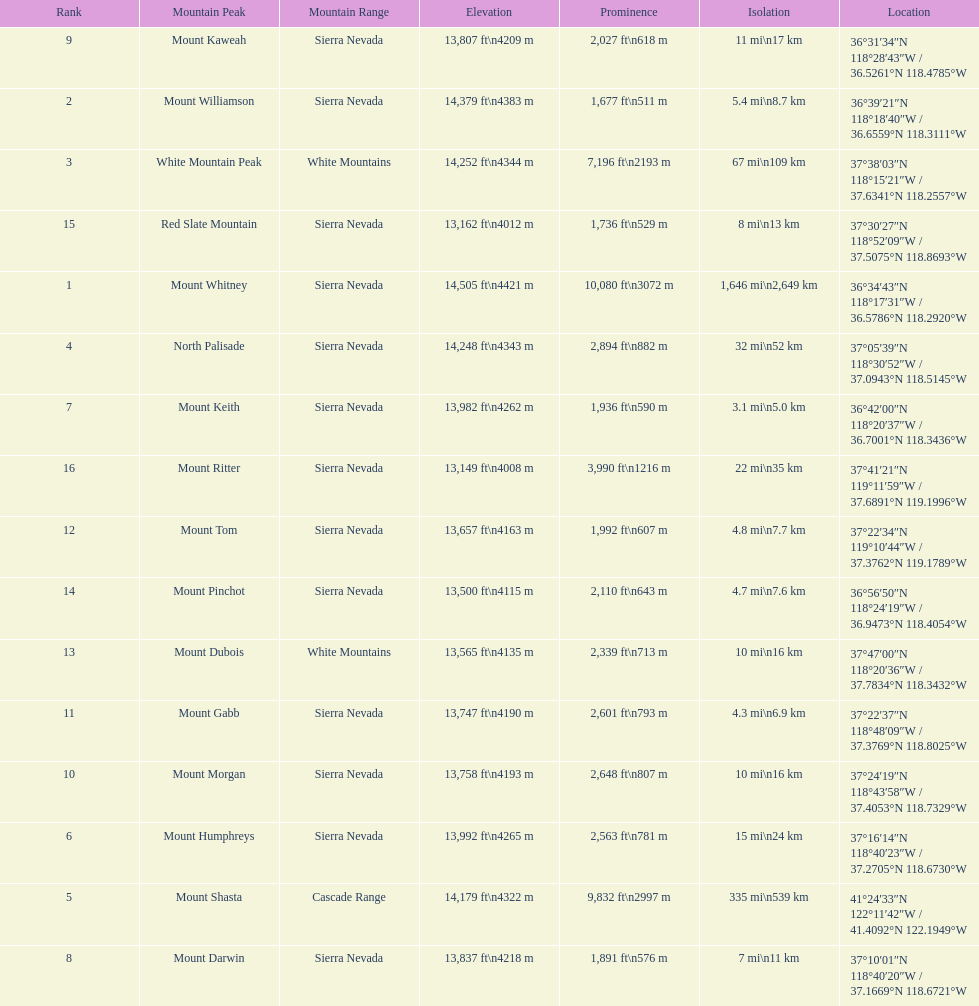What is the next highest mountain peak after north palisade? Mount Shasta. 